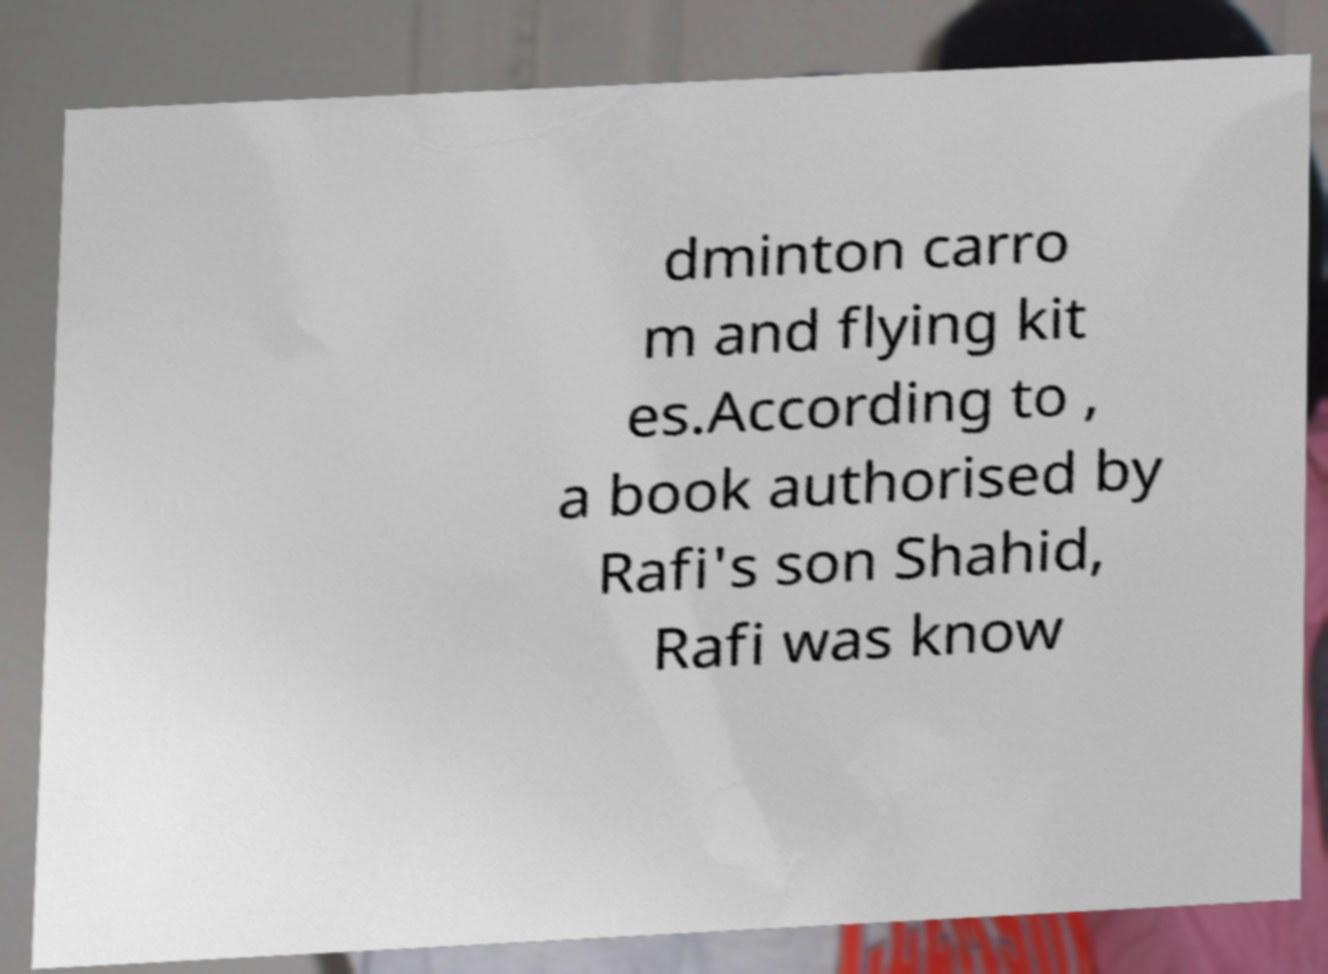Can you accurately transcribe the text from the provided image for me? dminton carro m and flying kit es.According to , a book authorised by Rafi's son Shahid, Rafi was know 